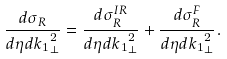<formula> <loc_0><loc_0><loc_500><loc_500>\frac { d \sigma _ { R } } { d \eta d { k _ { 1 } } _ { \perp } ^ { 2 } } = \frac { d \sigma _ { R } ^ { I R } } { d \eta d { k _ { 1 } } _ { \perp } ^ { 2 } } + \frac { d \sigma _ { R } ^ { F } } { d \eta d { k _ { 1 } } _ { \perp } ^ { 2 } } .</formula> 